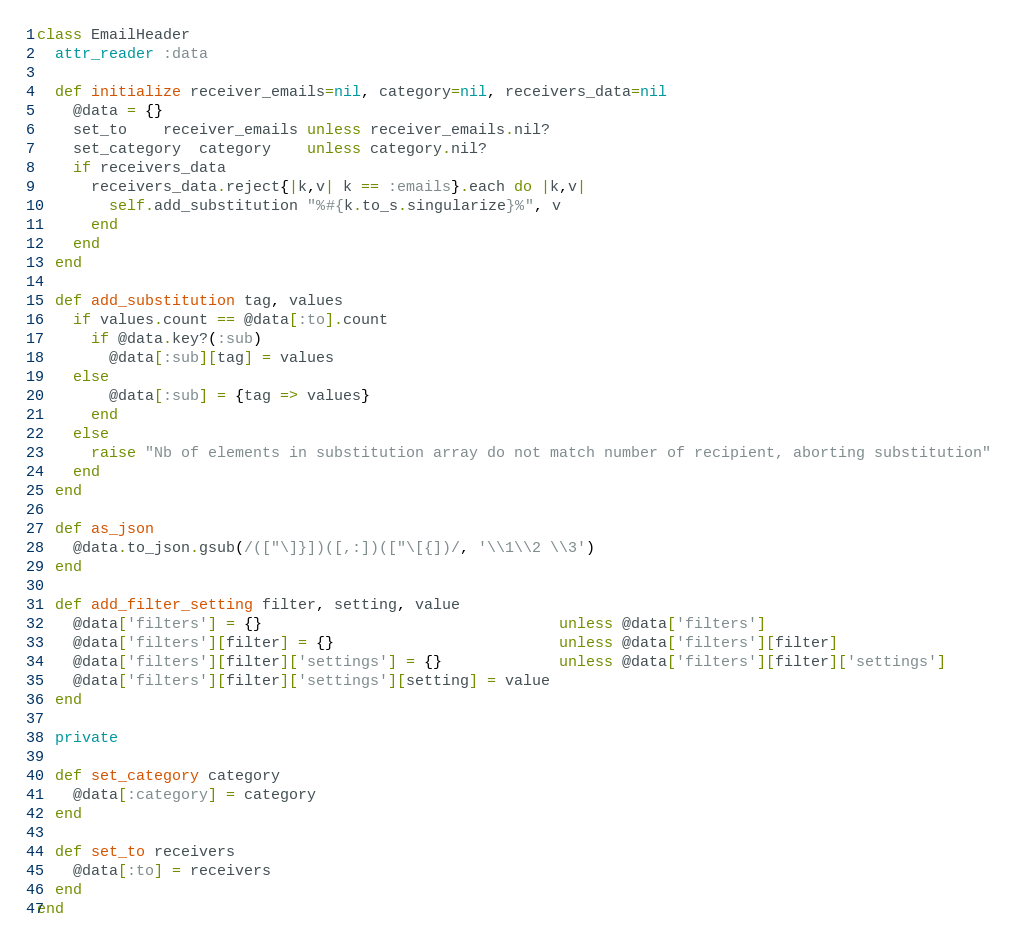<code> <loc_0><loc_0><loc_500><loc_500><_Ruby_>class EmailHeader
  attr_reader :data

  def initialize receiver_emails=nil, category=nil, receivers_data=nil
    @data = {}
    set_to    receiver_emails unless receiver_emails.nil?
    set_category  category    unless category.nil?
    if receivers_data
      receivers_data.reject{|k,v| k == :emails}.each do |k,v|
        self.add_substitution "%#{k.to_s.singularize}%", v
      end
    end
  end

  def add_substitution tag, values
    if values.count == @data[:to].count
      if @data.key?(:sub)
        @data[:sub][tag] = values
    else
        @data[:sub] = {tag => values}
      end
    else
      raise "Nb of elements in substitution array do not match number of recipient, aborting substitution"
    end
  end

  def as_json
    @data.to_json.gsub(/(["\]}])([,:])(["\[{])/, '\\1\\2 \\3')
  end

  def add_filter_setting filter, setting, value
    @data['filters'] = {}                                 unless @data['filters']
    @data['filters'][filter] = {}                         unless @data['filters'][filter]
    @data['filters'][filter]['settings'] = {}             unless @data['filters'][filter]['settings']
    @data['filters'][filter]['settings'][setting] = value
  end

  private

  def set_category category
    @data[:category] = category
  end

  def set_to receivers
    @data[:to] = receivers
  end
end</code> 